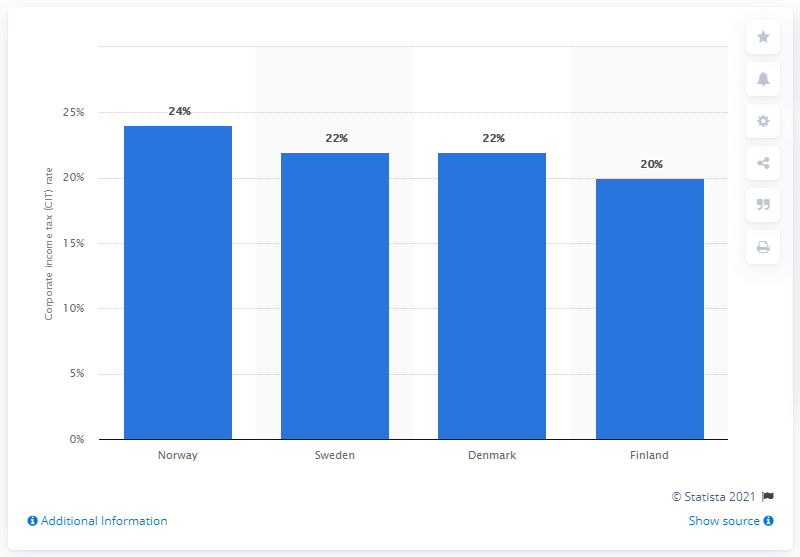Draw attention to some important aspects in this diagram. Finland had the lowest corporate income tax rate among the Nordic countries. In 2017, the corporate income tax rate in Norway was 24.. In 2017, the corporate income tax rate in Sweden and Denmark was 22%. 